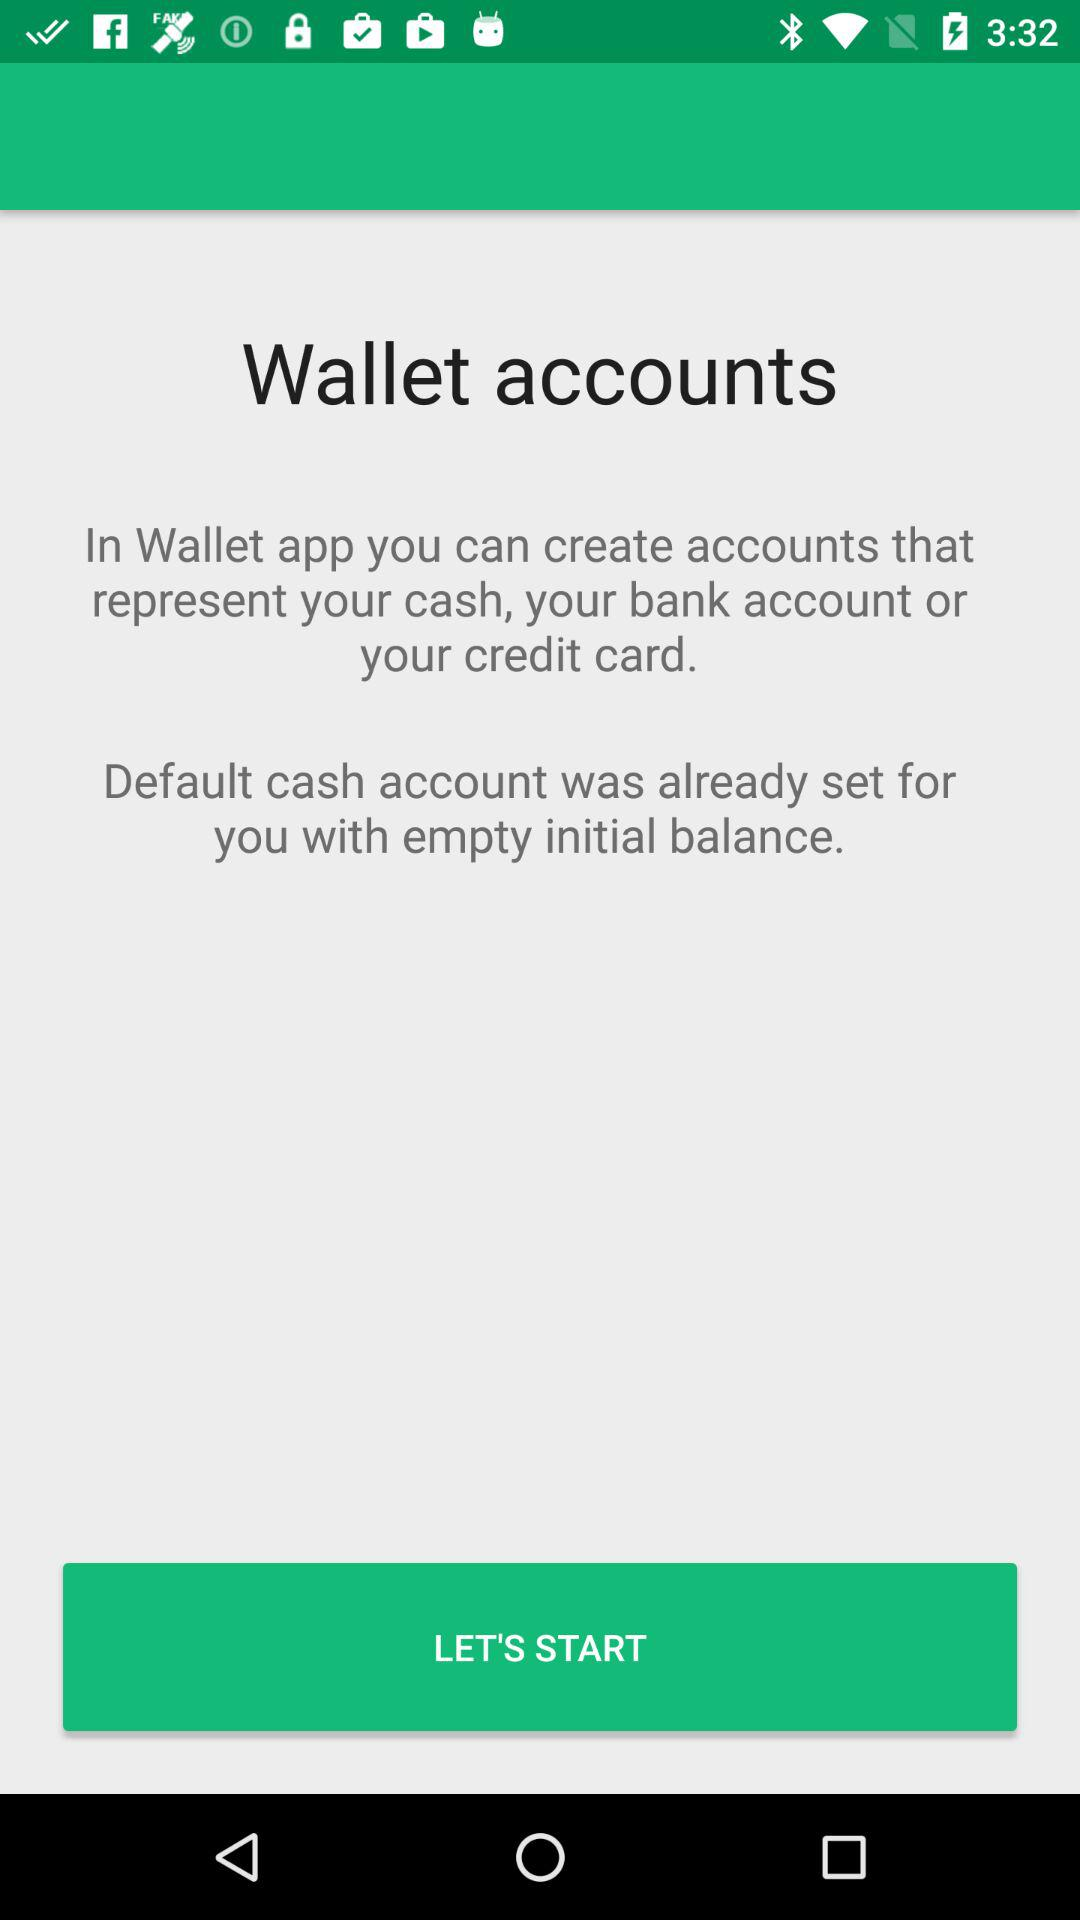How many lines of text are there on this screen?
Answer the question using a single word or phrase. 3 